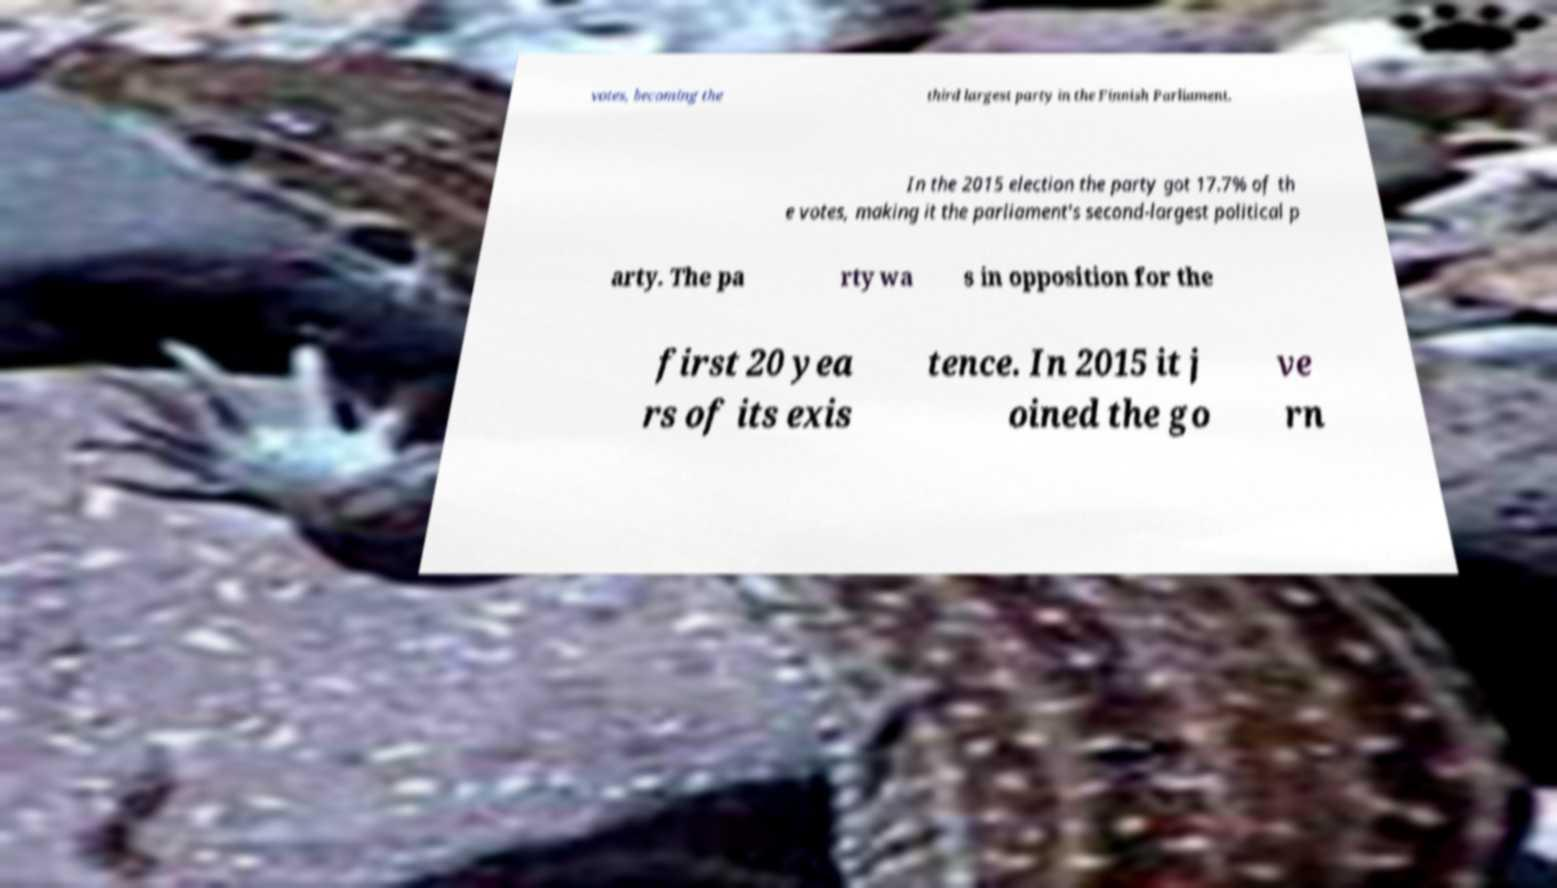Please identify and transcribe the text found in this image. votes, becoming the third largest party in the Finnish Parliament. In the 2015 election the party got 17.7% of th e votes, making it the parliament's second-largest political p arty. The pa rty wa s in opposition for the first 20 yea rs of its exis tence. In 2015 it j oined the go ve rn 